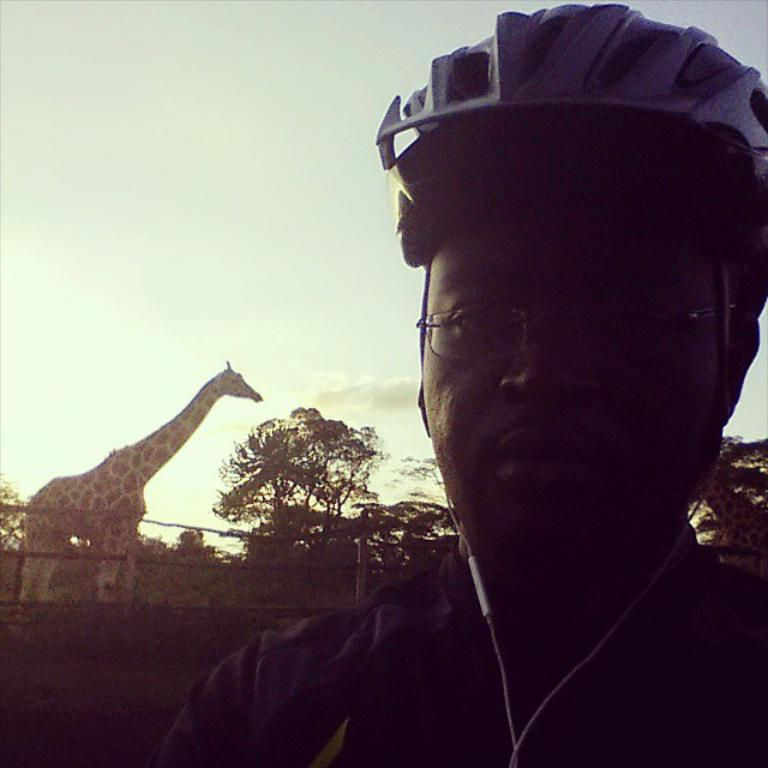Who or what is the main subject in the image? There is a person in the image. What is the person wearing on their head? The person is wearing a cap. What animal can be seen on the left side of the image? There is a giraffe on the left side of the image. What type of vegetation is in the middle of the image? There are trees in the middle of the image. What is visible at the top of the image? The sky is visible at the top of the image. How many times does the person attempt to control the number of trees in the image? There is no indication in the image that the person is attempting to control the number of trees or that they are even aware of the trees. 